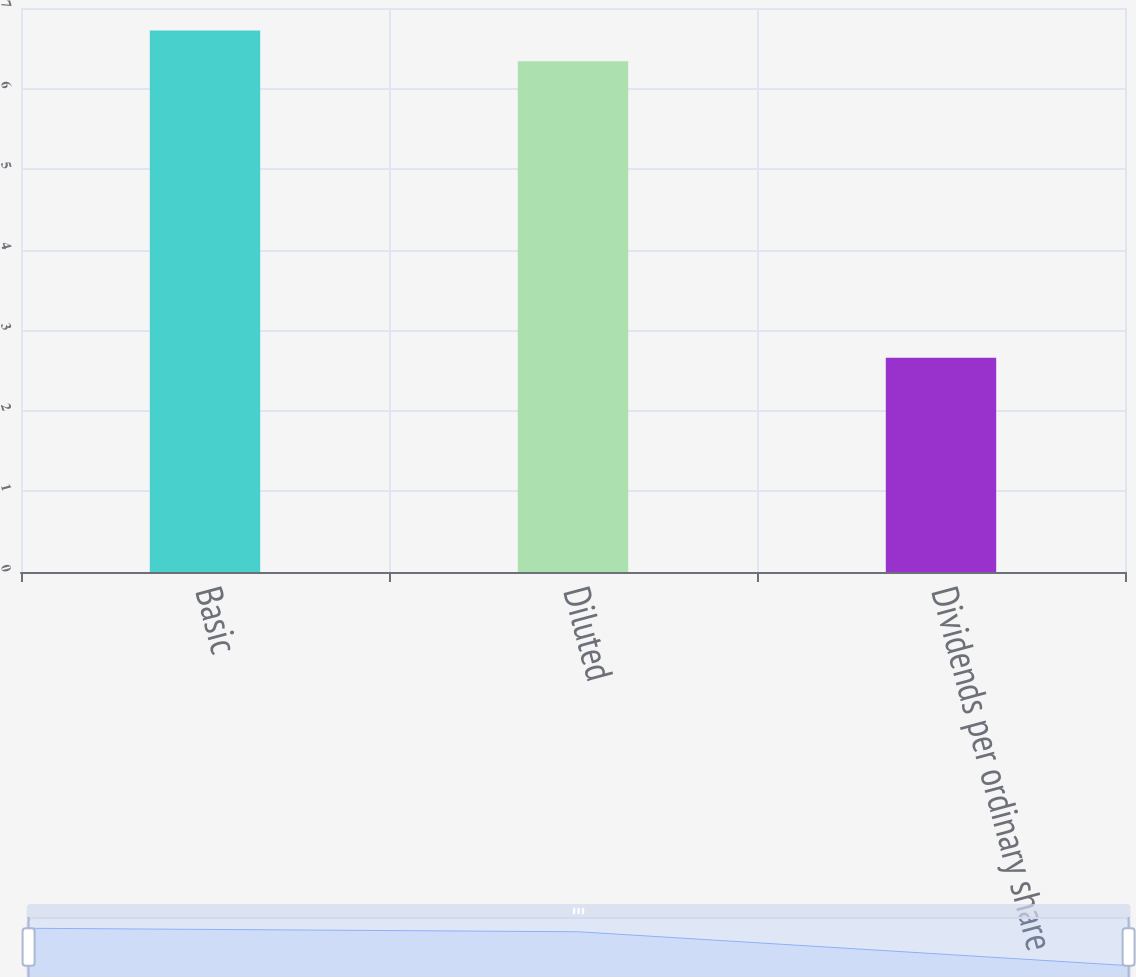<chart> <loc_0><loc_0><loc_500><loc_500><bar_chart><fcel>Basic<fcel>Diluted<fcel>Dividends per ordinary share<nl><fcel>6.72<fcel>6.34<fcel>2.66<nl></chart> 